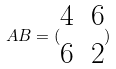<formula> <loc_0><loc_0><loc_500><loc_500>A B = ( \begin{matrix} 4 & 6 \\ 6 & 2 \end{matrix} )</formula> 